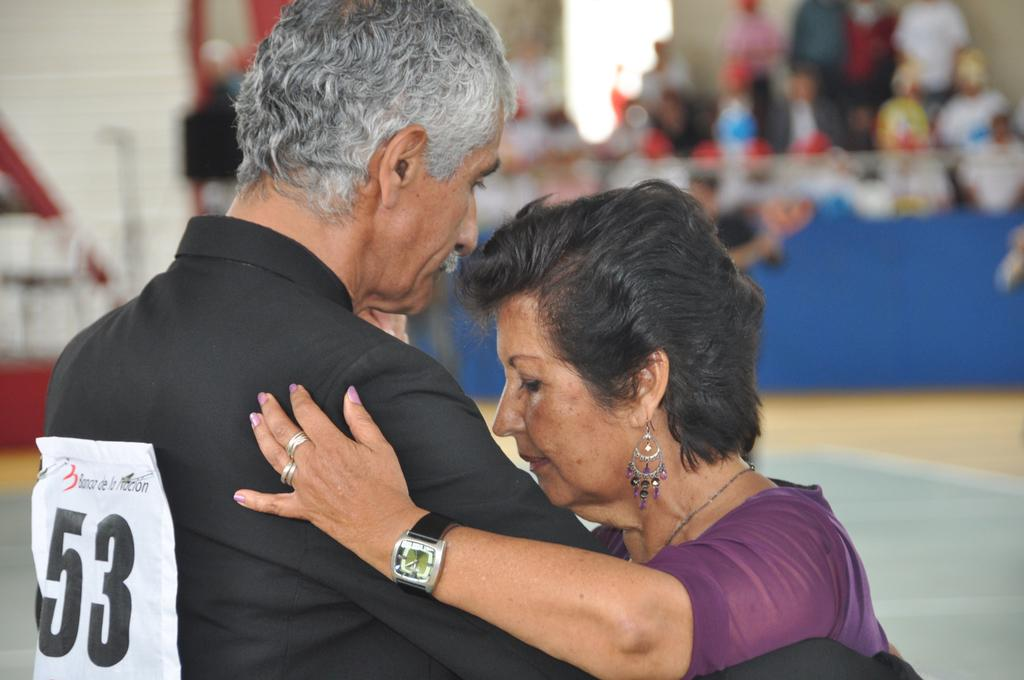What is the man in the image wearing? The man is wearing a black shirt in the image. What is the man doing with the woman in the image? The man is holding the woman in the image. What can be seen behind the board in the image? There is a group of people behind a board in the image. What type of surface is visible in the image? There is a floor visible in the image. What type of fairies can be seen flying around the man in the image? There are no fairies present in the image; it only features a man, a woman, and a group of people behind a board. What color is the woman's hair in the image? The provided facts do not mention the color of the woman's hair, so we cannot definitively answer that question. 